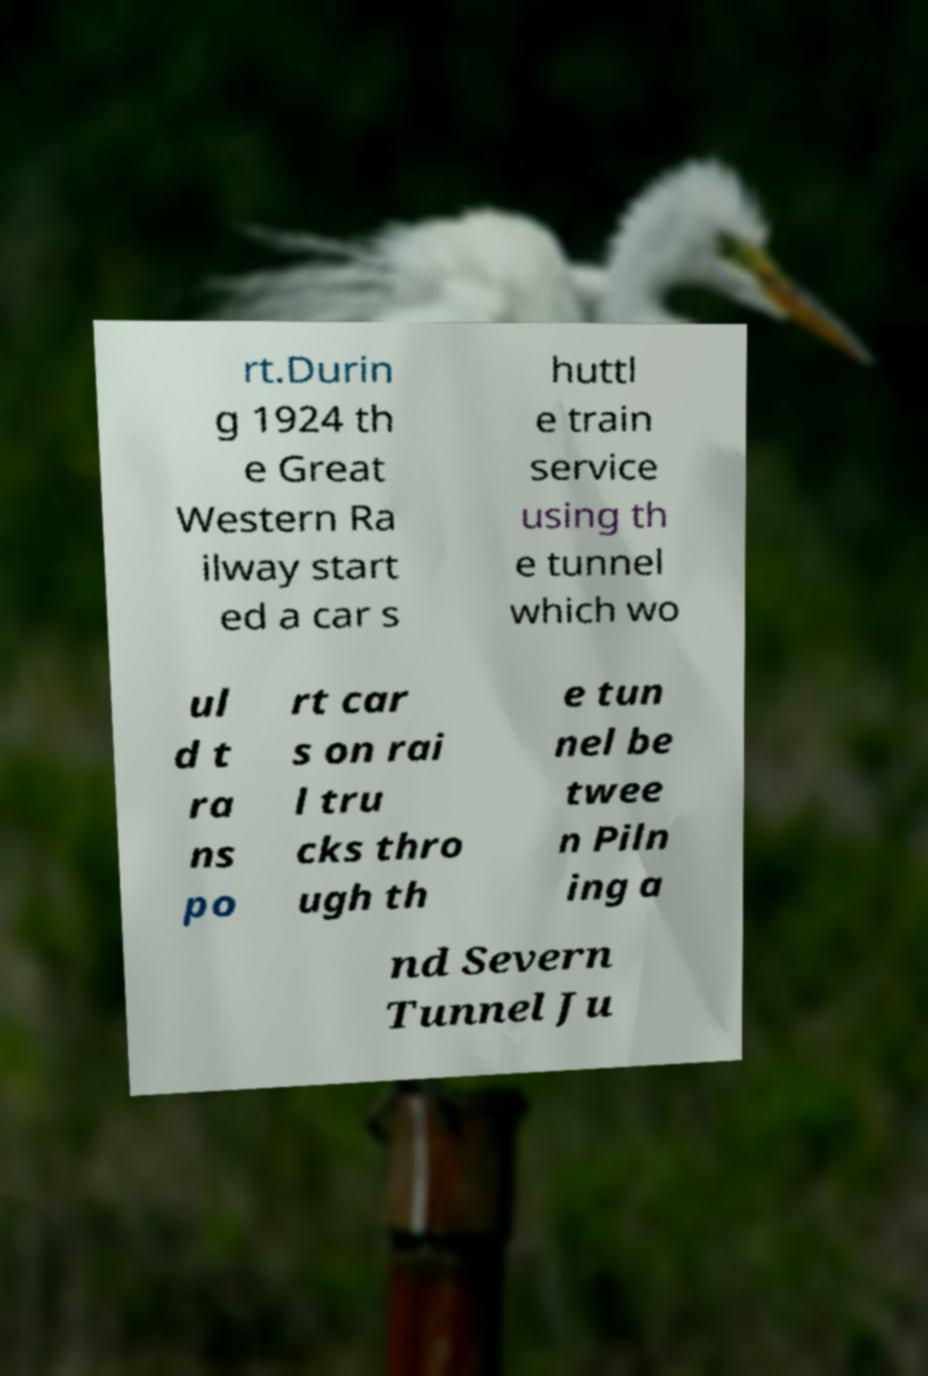I need the written content from this picture converted into text. Can you do that? rt.Durin g 1924 th e Great Western Ra ilway start ed a car s huttl e train service using th e tunnel which wo ul d t ra ns po rt car s on rai l tru cks thro ugh th e tun nel be twee n Piln ing a nd Severn Tunnel Ju 